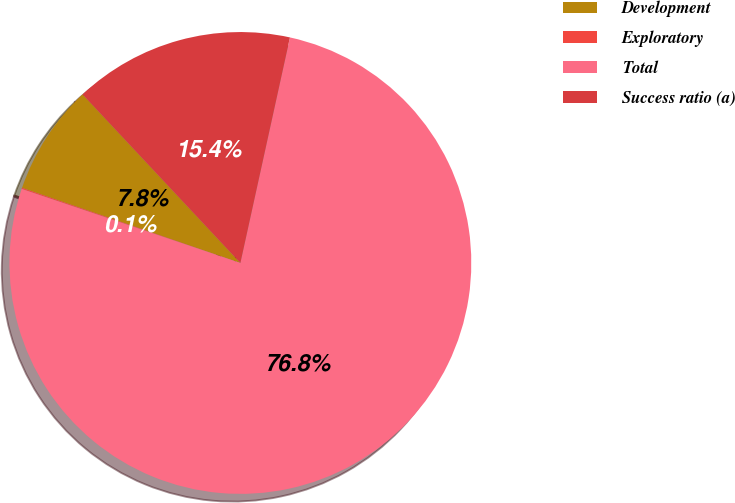<chart> <loc_0><loc_0><loc_500><loc_500><pie_chart><fcel>Development<fcel>Exploratory<fcel>Total<fcel>Success ratio (a)<nl><fcel>7.75%<fcel>0.08%<fcel>76.75%<fcel>15.42%<nl></chart> 